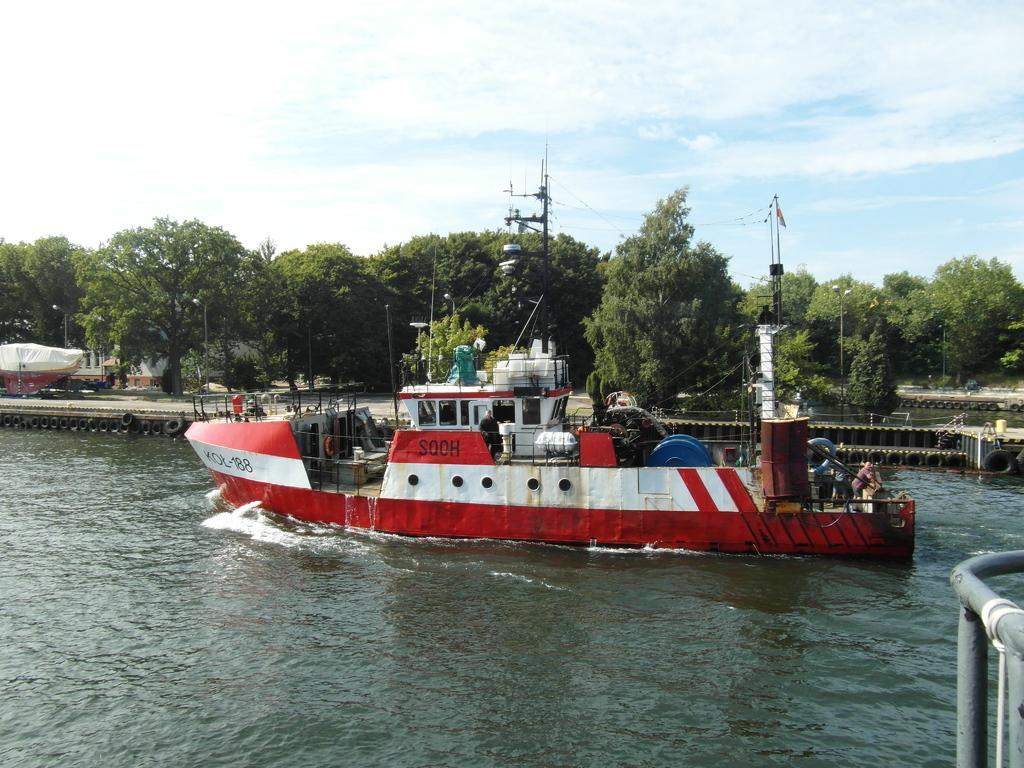In one or two sentences, can you explain what this image depicts? In this image there is the sky, there are trees, there are tyres, there is a boat in the river, there is an object truncated towards the right of the image. 